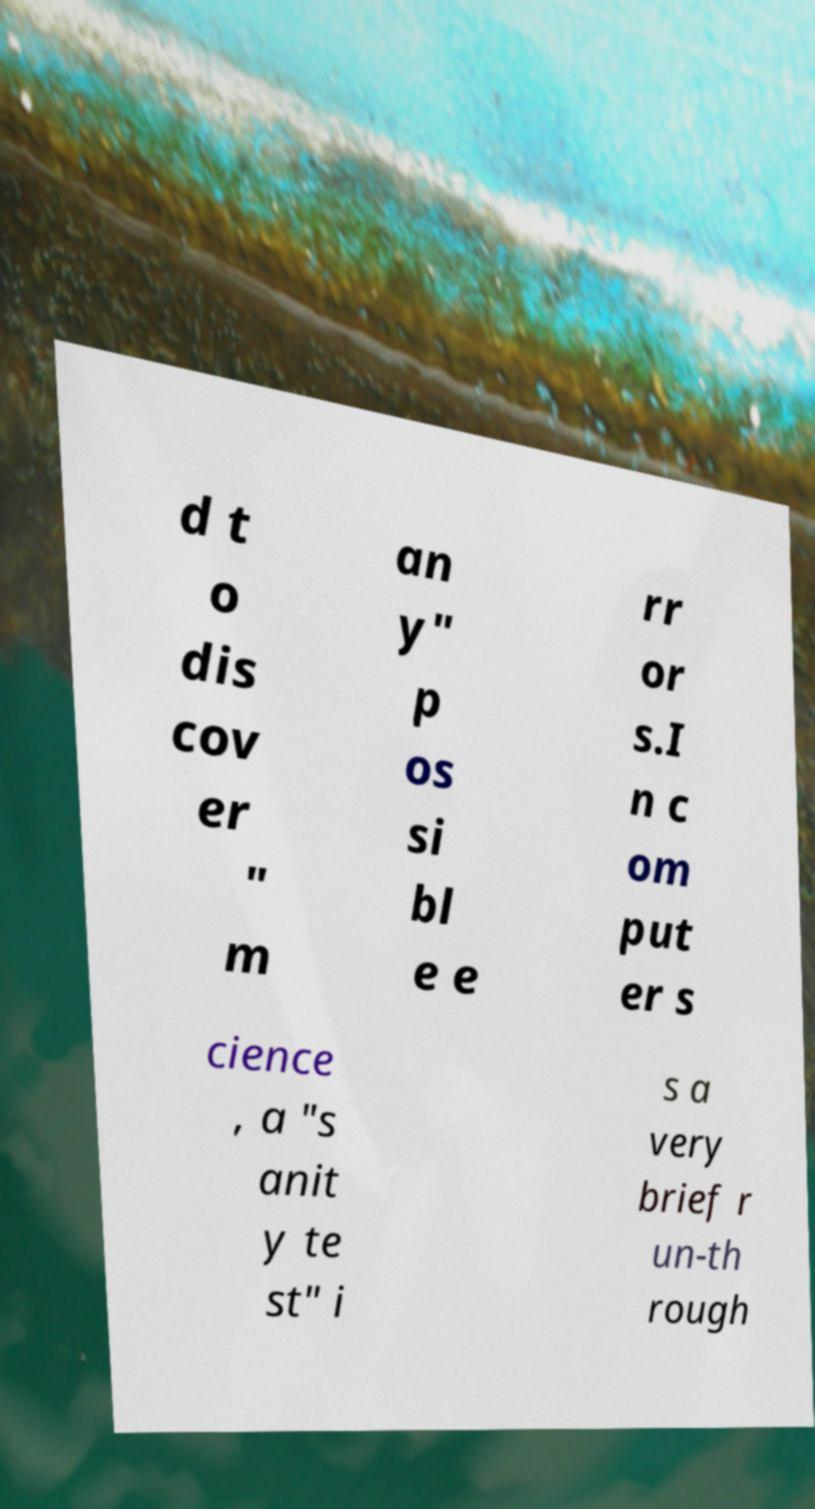Please identify and transcribe the text found in this image. d t o dis cov er " m an y" p os si bl e e rr or s.I n c om put er s cience , a "s anit y te st" i s a very brief r un-th rough 